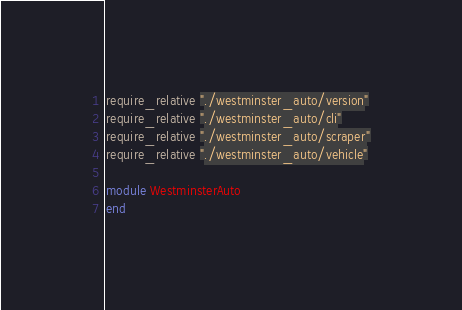<code> <loc_0><loc_0><loc_500><loc_500><_Ruby_>require_relative "./westminster_auto/version"
require_relative "./westminster_auto/cli"
require_relative "./westminster_auto/scraper"
require_relative "./westminster_auto/vehicle"

module WestminsterAuto
end

</code> 